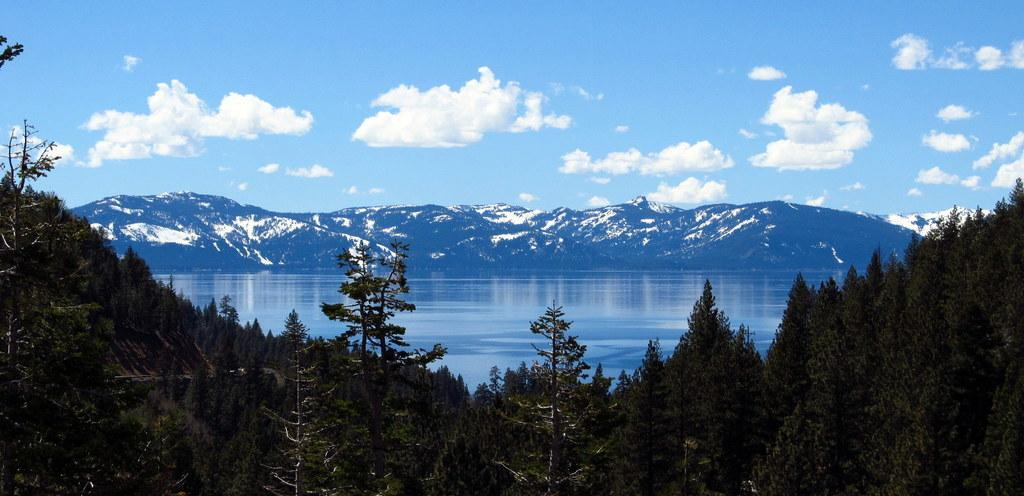What type of vegetation is in the foreground of the image? There are trees in the foreground of the image. What is visible behind the trees? There is a water surface visible behind the trees. What can be seen in the distance in the image? There are mountains in the background of the image. How many lizards are sitting on the cannon in the image? There is no cannon or lizards present in the image. What method is used to sort the mountains in the image? There is no sorting of mountains in the image; they are simply visible in the background. 